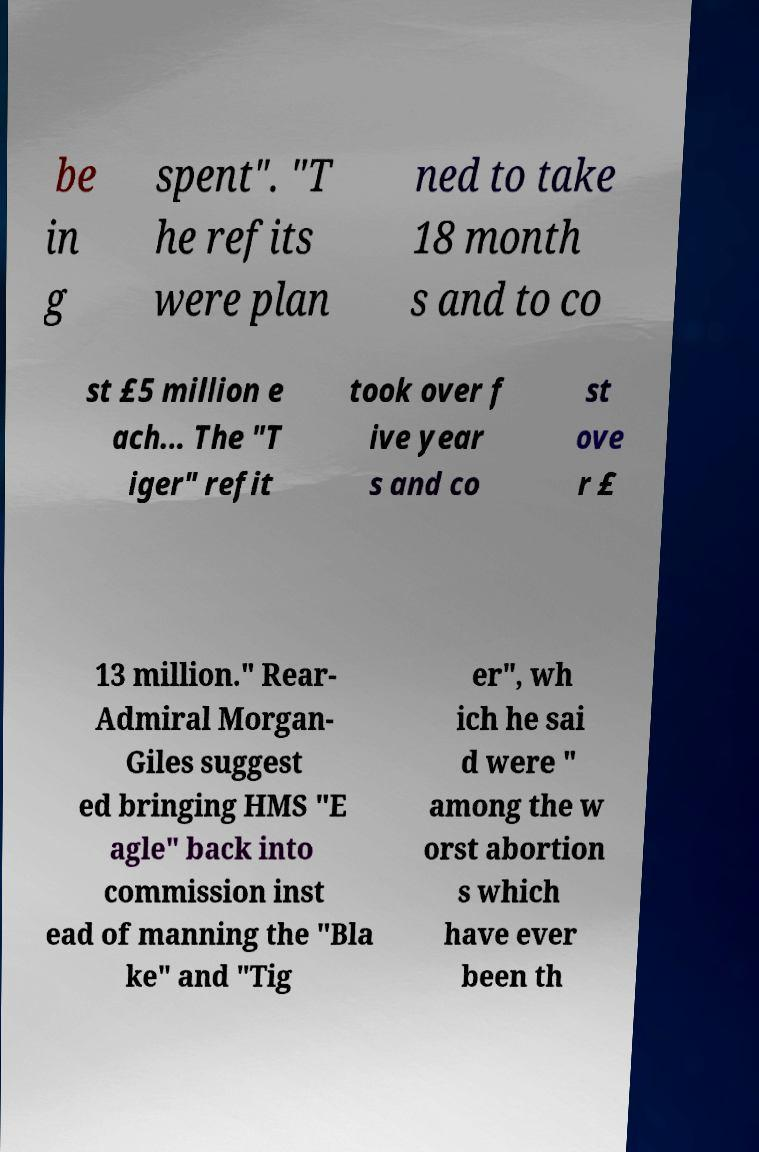What messages or text are displayed in this image? I need them in a readable, typed format. be in g spent". "T he refits were plan ned to take 18 month s and to co st £5 million e ach... The "T iger" refit took over f ive year s and co st ove r £ 13 million." Rear- Admiral Morgan- Giles suggest ed bringing HMS "E agle" back into commission inst ead of manning the "Bla ke" and "Tig er", wh ich he sai d were " among the w orst abortion s which have ever been th 